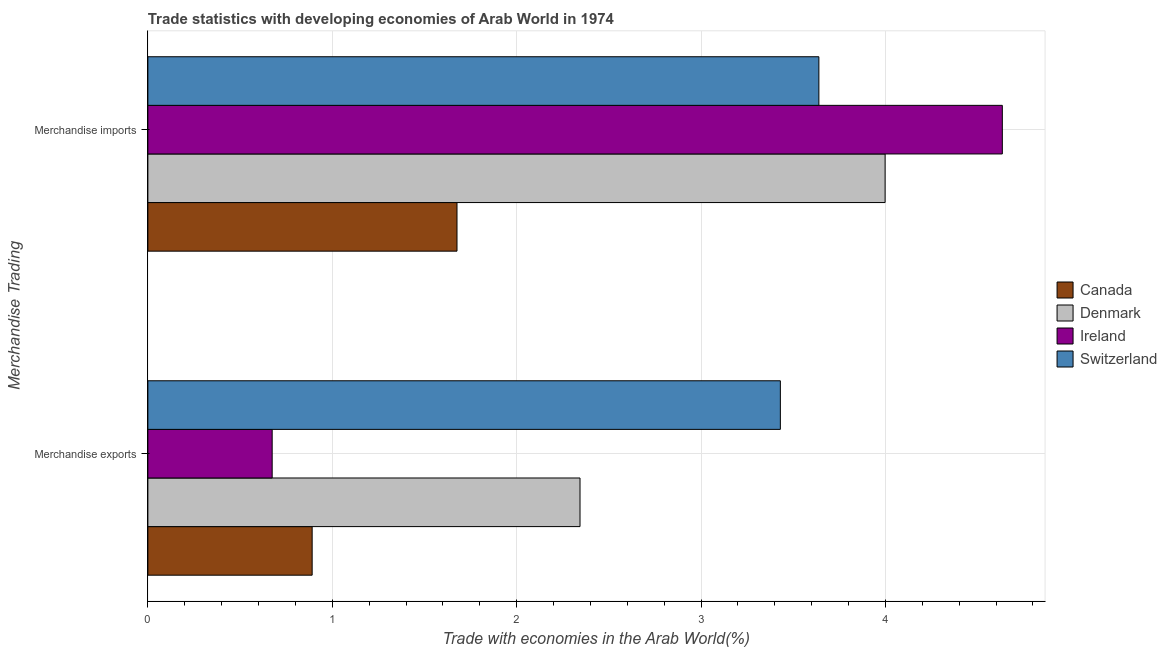Are the number of bars per tick equal to the number of legend labels?
Your answer should be compact. Yes. Are the number of bars on each tick of the Y-axis equal?
Keep it short and to the point. Yes. How many bars are there on the 2nd tick from the bottom?
Give a very brief answer. 4. What is the label of the 1st group of bars from the top?
Your answer should be very brief. Merchandise imports. What is the merchandise exports in Switzerland?
Make the answer very short. 3.43. Across all countries, what is the maximum merchandise imports?
Offer a terse response. 4.63. Across all countries, what is the minimum merchandise imports?
Your answer should be compact. 1.68. In which country was the merchandise imports maximum?
Make the answer very short. Ireland. In which country was the merchandise exports minimum?
Give a very brief answer. Ireland. What is the total merchandise imports in the graph?
Your answer should be very brief. 13.95. What is the difference between the merchandise exports in Ireland and that in Switzerland?
Give a very brief answer. -2.76. What is the difference between the merchandise imports in Ireland and the merchandise exports in Switzerland?
Your answer should be compact. 1.2. What is the average merchandise imports per country?
Provide a succinct answer. 3.49. What is the difference between the merchandise imports and merchandise exports in Switzerland?
Your answer should be compact. 0.21. In how many countries, is the merchandise exports greater than 3.4 %?
Give a very brief answer. 1. What is the ratio of the merchandise exports in Switzerland to that in Canada?
Offer a very short reply. 3.85. In how many countries, is the merchandise imports greater than the average merchandise imports taken over all countries?
Make the answer very short. 3. What does the 1st bar from the top in Merchandise exports represents?
Provide a succinct answer. Switzerland. Are all the bars in the graph horizontal?
Make the answer very short. Yes. Are the values on the major ticks of X-axis written in scientific E-notation?
Ensure brevity in your answer.  No. What is the title of the graph?
Offer a very short reply. Trade statistics with developing economies of Arab World in 1974. Does "Mauritania" appear as one of the legend labels in the graph?
Offer a terse response. No. What is the label or title of the X-axis?
Ensure brevity in your answer.  Trade with economies in the Arab World(%). What is the label or title of the Y-axis?
Provide a succinct answer. Merchandise Trading. What is the Trade with economies in the Arab World(%) of Canada in Merchandise exports?
Your answer should be compact. 0.89. What is the Trade with economies in the Arab World(%) in Denmark in Merchandise exports?
Offer a very short reply. 2.34. What is the Trade with economies in the Arab World(%) of Ireland in Merchandise exports?
Offer a very short reply. 0.67. What is the Trade with economies in the Arab World(%) in Switzerland in Merchandise exports?
Your response must be concise. 3.43. What is the Trade with economies in the Arab World(%) in Canada in Merchandise imports?
Your answer should be very brief. 1.68. What is the Trade with economies in the Arab World(%) in Denmark in Merchandise imports?
Make the answer very short. 4. What is the Trade with economies in the Arab World(%) of Ireland in Merchandise imports?
Your answer should be very brief. 4.63. What is the Trade with economies in the Arab World(%) of Switzerland in Merchandise imports?
Your answer should be compact. 3.64. Across all Merchandise Trading, what is the maximum Trade with economies in the Arab World(%) of Canada?
Your response must be concise. 1.68. Across all Merchandise Trading, what is the maximum Trade with economies in the Arab World(%) of Denmark?
Keep it short and to the point. 4. Across all Merchandise Trading, what is the maximum Trade with economies in the Arab World(%) in Ireland?
Your answer should be compact. 4.63. Across all Merchandise Trading, what is the maximum Trade with economies in the Arab World(%) of Switzerland?
Keep it short and to the point. 3.64. Across all Merchandise Trading, what is the minimum Trade with economies in the Arab World(%) of Canada?
Offer a terse response. 0.89. Across all Merchandise Trading, what is the minimum Trade with economies in the Arab World(%) of Denmark?
Your answer should be very brief. 2.34. Across all Merchandise Trading, what is the minimum Trade with economies in the Arab World(%) of Ireland?
Provide a short and direct response. 0.67. Across all Merchandise Trading, what is the minimum Trade with economies in the Arab World(%) in Switzerland?
Offer a very short reply. 3.43. What is the total Trade with economies in the Arab World(%) of Canada in the graph?
Your answer should be very brief. 2.57. What is the total Trade with economies in the Arab World(%) of Denmark in the graph?
Provide a short and direct response. 6.34. What is the total Trade with economies in the Arab World(%) of Ireland in the graph?
Give a very brief answer. 5.31. What is the total Trade with economies in the Arab World(%) of Switzerland in the graph?
Your answer should be very brief. 7.07. What is the difference between the Trade with economies in the Arab World(%) in Canada in Merchandise exports and that in Merchandise imports?
Give a very brief answer. -0.79. What is the difference between the Trade with economies in the Arab World(%) in Denmark in Merchandise exports and that in Merchandise imports?
Ensure brevity in your answer.  -1.65. What is the difference between the Trade with economies in the Arab World(%) of Ireland in Merchandise exports and that in Merchandise imports?
Ensure brevity in your answer.  -3.96. What is the difference between the Trade with economies in the Arab World(%) in Switzerland in Merchandise exports and that in Merchandise imports?
Offer a terse response. -0.21. What is the difference between the Trade with economies in the Arab World(%) of Canada in Merchandise exports and the Trade with economies in the Arab World(%) of Denmark in Merchandise imports?
Your response must be concise. -3.11. What is the difference between the Trade with economies in the Arab World(%) in Canada in Merchandise exports and the Trade with economies in the Arab World(%) in Ireland in Merchandise imports?
Offer a terse response. -3.74. What is the difference between the Trade with economies in the Arab World(%) in Canada in Merchandise exports and the Trade with economies in the Arab World(%) in Switzerland in Merchandise imports?
Your response must be concise. -2.75. What is the difference between the Trade with economies in the Arab World(%) of Denmark in Merchandise exports and the Trade with economies in the Arab World(%) of Ireland in Merchandise imports?
Provide a short and direct response. -2.29. What is the difference between the Trade with economies in the Arab World(%) in Denmark in Merchandise exports and the Trade with economies in the Arab World(%) in Switzerland in Merchandise imports?
Offer a very short reply. -1.3. What is the difference between the Trade with economies in the Arab World(%) in Ireland in Merchandise exports and the Trade with economies in the Arab World(%) in Switzerland in Merchandise imports?
Offer a terse response. -2.96. What is the average Trade with economies in the Arab World(%) in Canada per Merchandise Trading?
Offer a very short reply. 1.28. What is the average Trade with economies in the Arab World(%) in Denmark per Merchandise Trading?
Ensure brevity in your answer.  3.17. What is the average Trade with economies in the Arab World(%) of Ireland per Merchandise Trading?
Offer a terse response. 2.65. What is the average Trade with economies in the Arab World(%) in Switzerland per Merchandise Trading?
Keep it short and to the point. 3.53. What is the difference between the Trade with economies in the Arab World(%) of Canada and Trade with economies in the Arab World(%) of Denmark in Merchandise exports?
Make the answer very short. -1.45. What is the difference between the Trade with economies in the Arab World(%) in Canada and Trade with economies in the Arab World(%) in Ireland in Merchandise exports?
Offer a very short reply. 0.22. What is the difference between the Trade with economies in the Arab World(%) of Canada and Trade with economies in the Arab World(%) of Switzerland in Merchandise exports?
Keep it short and to the point. -2.54. What is the difference between the Trade with economies in the Arab World(%) in Denmark and Trade with economies in the Arab World(%) in Ireland in Merchandise exports?
Your answer should be very brief. 1.67. What is the difference between the Trade with economies in the Arab World(%) in Denmark and Trade with economies in the Arab World(%) in Switzerland in Merchandise exports?
Keep it short and to the point. -1.09. What is the difference between the Trade with economies in the Arab World(%) in Ireland and Trade with economies in the Arab World(%) in Switzerland in Merchandise exports?
Make the answer very short. -2.76. What is the difference between the Trade with economies in the Arab World(%) in Canada and Trade with economies in the Arab World(%) in Denmark in Merchandise imports?
Your answer should be compact. -2.32. What is the difference between the Trade with economies in the Arab World(%) of Canada and Trade with economies in the Arab World(%) of Ireland in Merchandise imports?
Make the answer very short. -2.96. What is the difference between the Trade with economies in the Arab World(%) in Canada and Trade with economies in the Arab World(%) in Switzerland in Merchandise imports?
Give a very brief answer. -1.96. What is the difference between the Trade with economies in the Arab World(%) of Denmark and Trade with economies in the Arab World(%) of Ireland in Merchandise imports?
Make the answer very short. -0.64. What is the difference between the Trade with economies in the Arab World(%) of Denmark and Trade with economies in the Arab World(%) of Switzerland in Merchandise imports?
Ensure brevity in your answer.  0.36. What is the ratio of the Trade with economies in the Arab World(%) in Canada in Merchandise exports to that in Merchandise imports?
Make the answer very short. 0.53. What is the ratio of the Trade with economies in the Arab World(%) in Denmark in Merchandise exports to that in Merchandise imports?
Provide a succinct answer. 0.59. What is the ratio of the Trade with economies in the Arab World(%) of Ireland in Merchandise exports to that in Merchandise imports?
Offer a very short reply. 0.15. What is the ratio of the Trade with economies in the Arab World(%) of Switzerland in Merchandise exports to that in Merchandise imports?
Your answer should be very brief. 0.94. What is the difference between the highest and the second highest Trade with economies in the Arab World(%) of Canada?
Offer a terse response. 0.79. What is the difference between the highest and the second highest Trade with economies in the Arab World(%) of Denmark?
Offer a terse response. 1.65. What is the difference between the highest and the second highest Trade with economies in the Arab World(%) of Ireland?
Give a very brief answer. 3.96. What is the difference between the highest and the second highest Trade with economies in the Arab World(%) of Switzerland?
Give a very brief answer. 0.21. What is the difference between the highest and the lowest Trade with economies in the Arab World(%) in Canada?
Provide a short and direct response. 0.79. What is the difference between the highest and the lowest Trade with economies in the Arab World(%) in Denmark?
Give a very brief answer. 1.65. What is the difference between the highest and the lowest Trade with economies in the Arab World(%) of Ireland?
Your answer should be very brief. 3.96. What is the difference between the highest and the lowest Trade with economies in the Arab World(%) in Switzerland?
Make the answer very short. 0.21. 